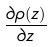<formula> <loc_0><loc_0><loc_500><loc_500>\frac { \partial \rho ( z ) } { \partial z }</formula> 